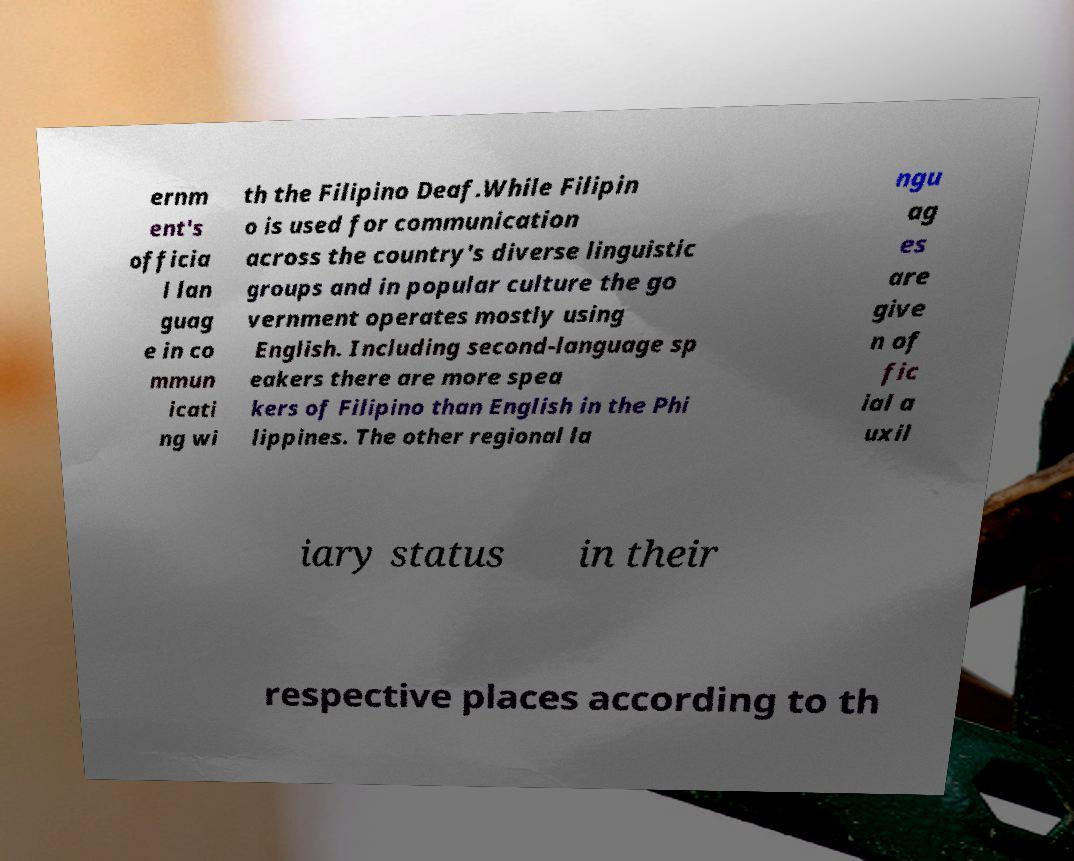Can you accurately transcribe the text from the provided image for me? ernm ent's officia l lan guag e in co mmun icati ng wi th the Filipino Deaf.While Filipin o is used for communication across the country's diverse linguistic groups and in popular culture the go vernment operates mostly using English. Including second-language sp eakers there are more spea kers of Filipino than English in the Phi lippines. The other regional la ngu ag es are give n of fic ial a uxil iary status in their respective places according to th 